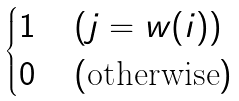<formula> <loc_0><loc_0><loc_500><loc_500>\begin{cases} 1 \, & ( j = w ( i ) ) \\ 0 \, & ( \text {otherwise} ) \end{cases}</formula> 